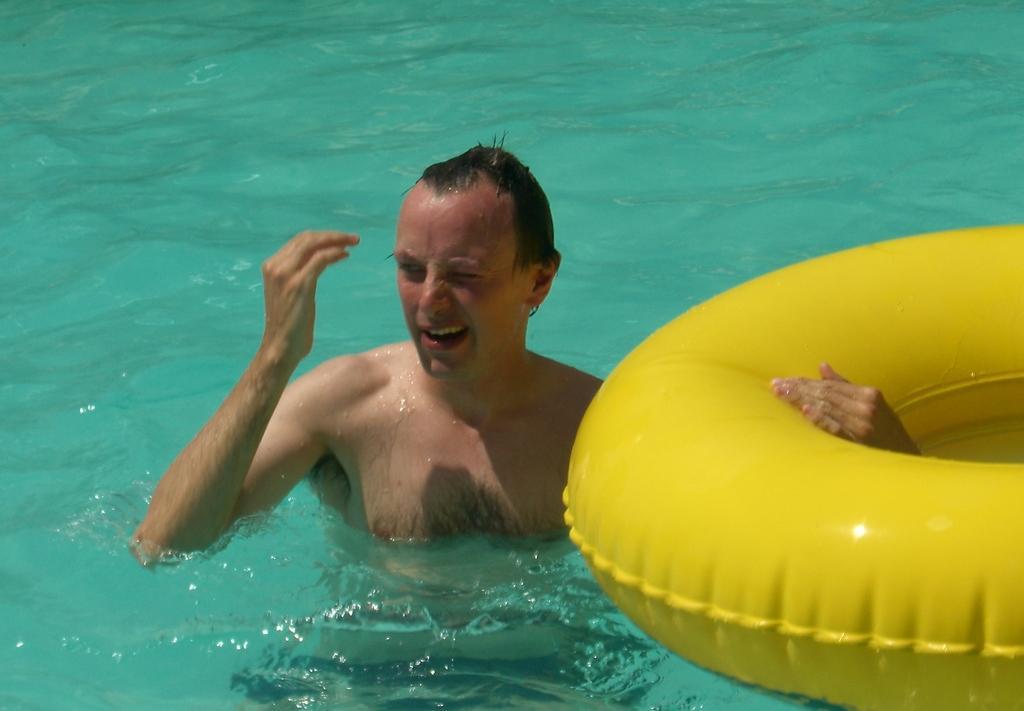How would you summarize this image in a sentence or two? In this picture I can observe a man in the water. On the right side there is yellow color inflatable ring floating on the water. In the background there is water. 